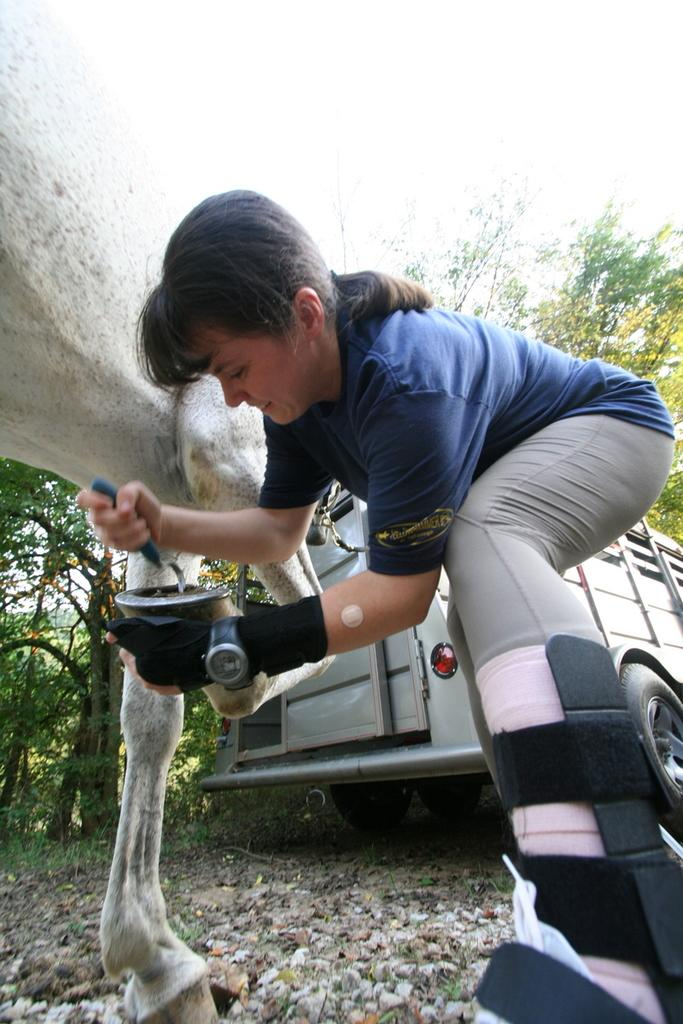What is the person in the image doing with the objects they are holding? The person is holding objects in the image, but the specific action cannot be determined from the provided facts. What type of animal is present in the image? There is an animal in the image in the image, but the specific type cannot be determined from the provided facts. What is the vehicle on the ground in the image? The vehicle on the ground in the image is not described in the provided facts. What can be seen in the background of the image? In the background of the image, there are trees and the sky. How many teeth can be seen in the mouth of the animal in the image? There is no mention of the animal's mouth or teeth in the provided facts, so it cannot be determined from the image. What type of town is visible in the background of the image? There is no town present in the image; only trees and the sky are visible in the background. 